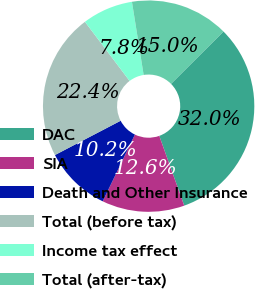Convert chart to OTSL. <chart><loc_0><loc_0><loc_500><loc_500><pie_chart><fcel>DAC<fcel>SIA<fcel>Death and Other Insurance<fcel>Total (before tax)<fcel>Income tax effect<fcel>Total (after-tax)<nl><fcel>32.02%<fcel>12.62%<fcel>10.19%<fcel>22.36%<fcel>7.77%<fcel>15.04%<nl></chart> 